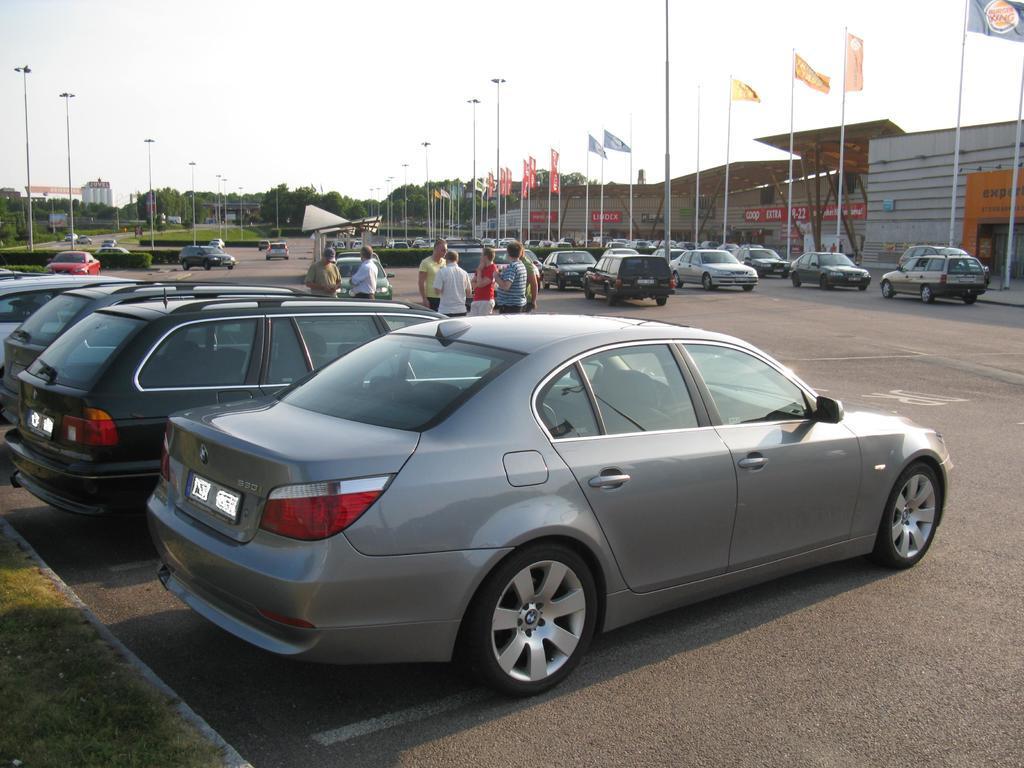Describe this image in one or two sentences. In this image, I can see vehicles and a group of people standing on the road. I can see bushes, buildings, flags, trees and poles. In the background, there is the sky. 